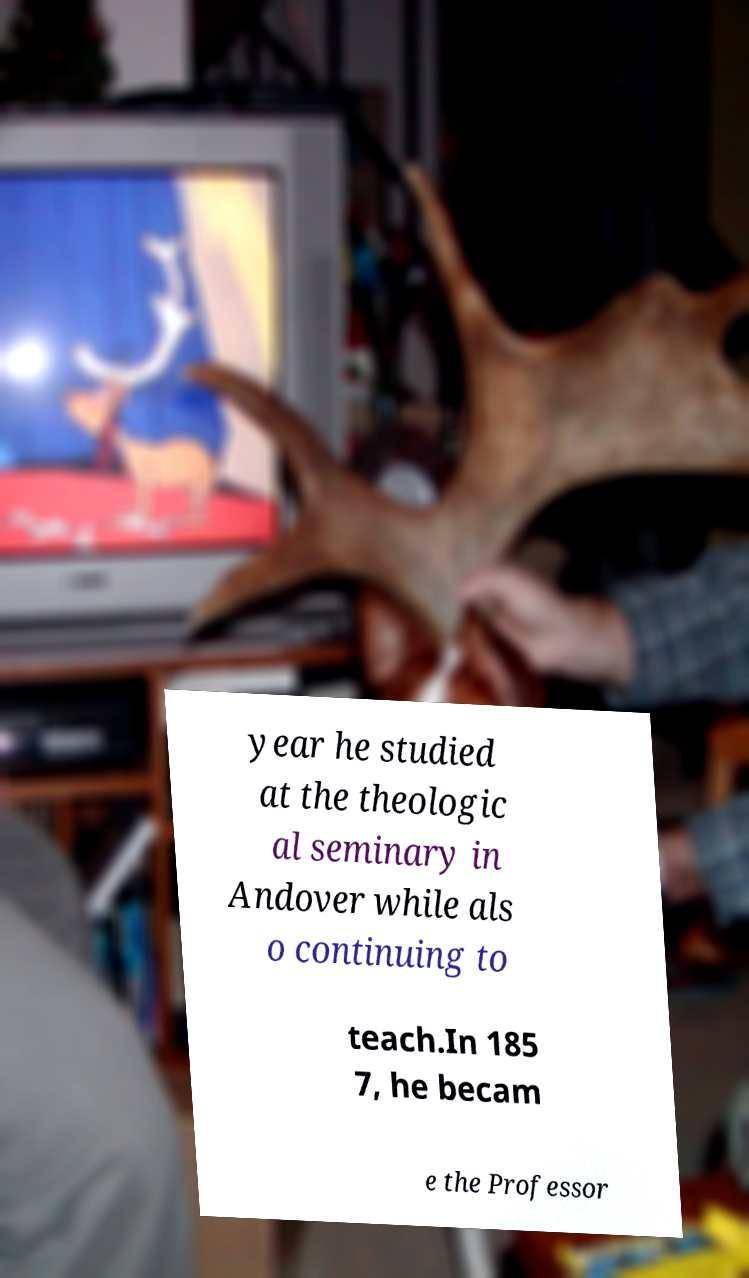Can you read and provide the text displayed in the image?This photo seems to have some interesting text. Can you extract and type it out for me? year he studied at the theologic al seminary in Andover while als o continuing to teach.In 185 7, he becam e the Professor 